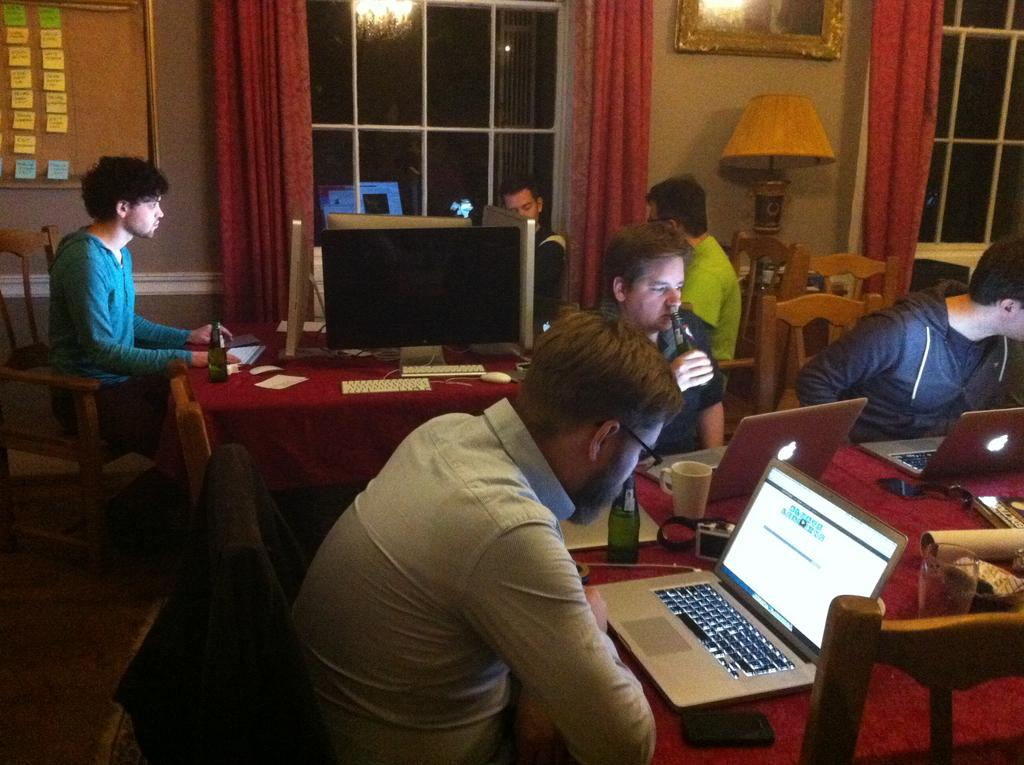How many people are in the image? There is a group of people in the image. What are the people doing in the image? The people are sitting on a chair. Where is the chair located in relation to the table? The chair is in front of a table. What electronic device is on the table? There is a laptop on the table. What other objects can be seen on the table? There are other objects on the table. Can you see a hook attached to the boat in the image? There is no boat or hook present in the image. What type of mine is visible in the image? There is no mine present in the image. 